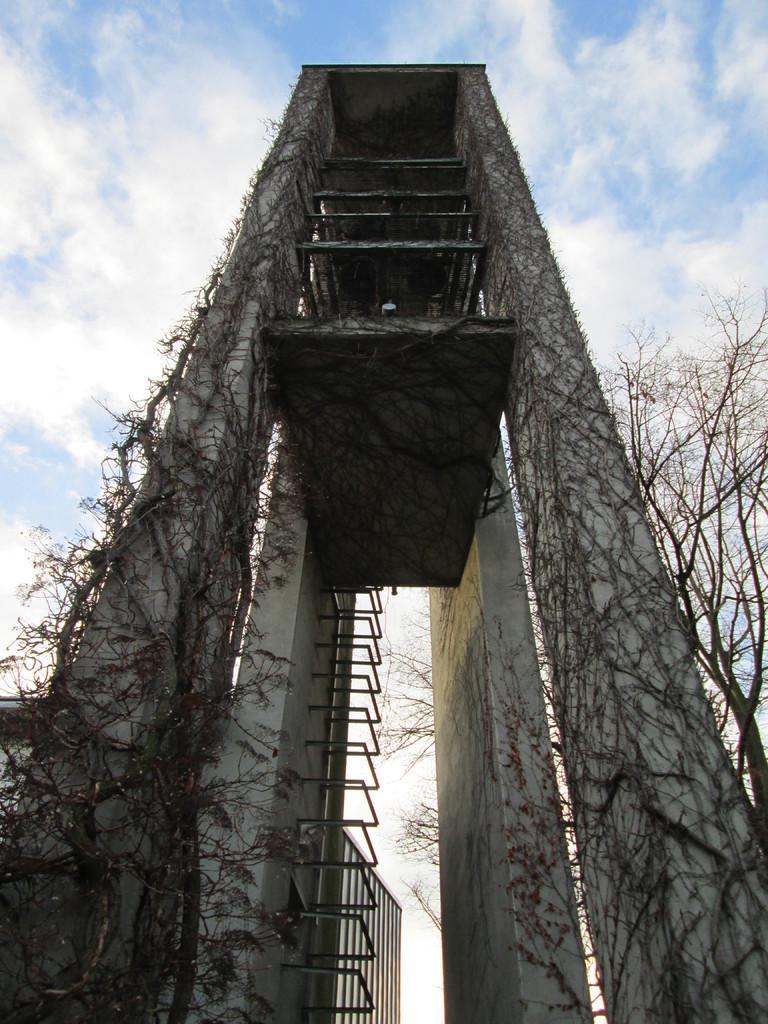How would you summarize this image in a sentence or two? This picture is clicked outside. In the foreground we can see a tower like object and we can see the metal rods, dry stems and branches of the trees. In the background we can see the sky with the clouds. 